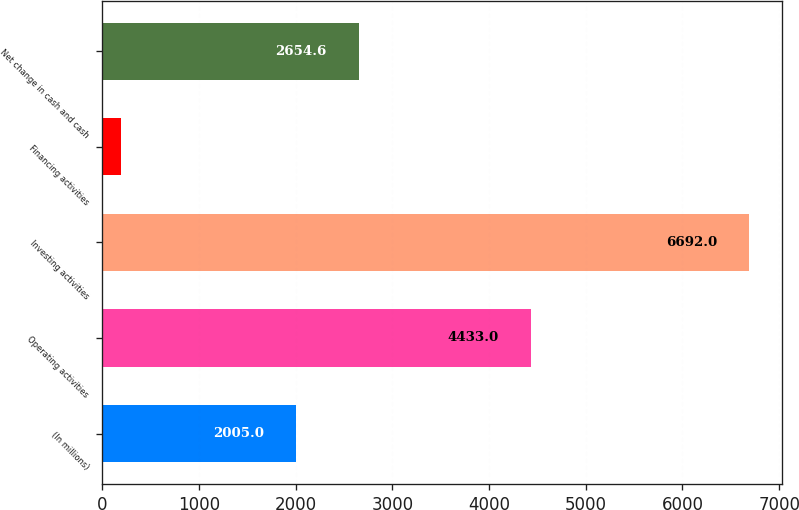Convert chart. <chart><loc_0><loc_0><loc_500><loc_500><bar_chart><fcel>(In millions)<fcel>Operating activities<fcel>Investing activities<fcel>Financing activities<fcel>Net change in cash and cash<nl><fcel>2005<fcel>4433<fcel>6692<fcel>196<fcel>2654.6<nl></chart> 